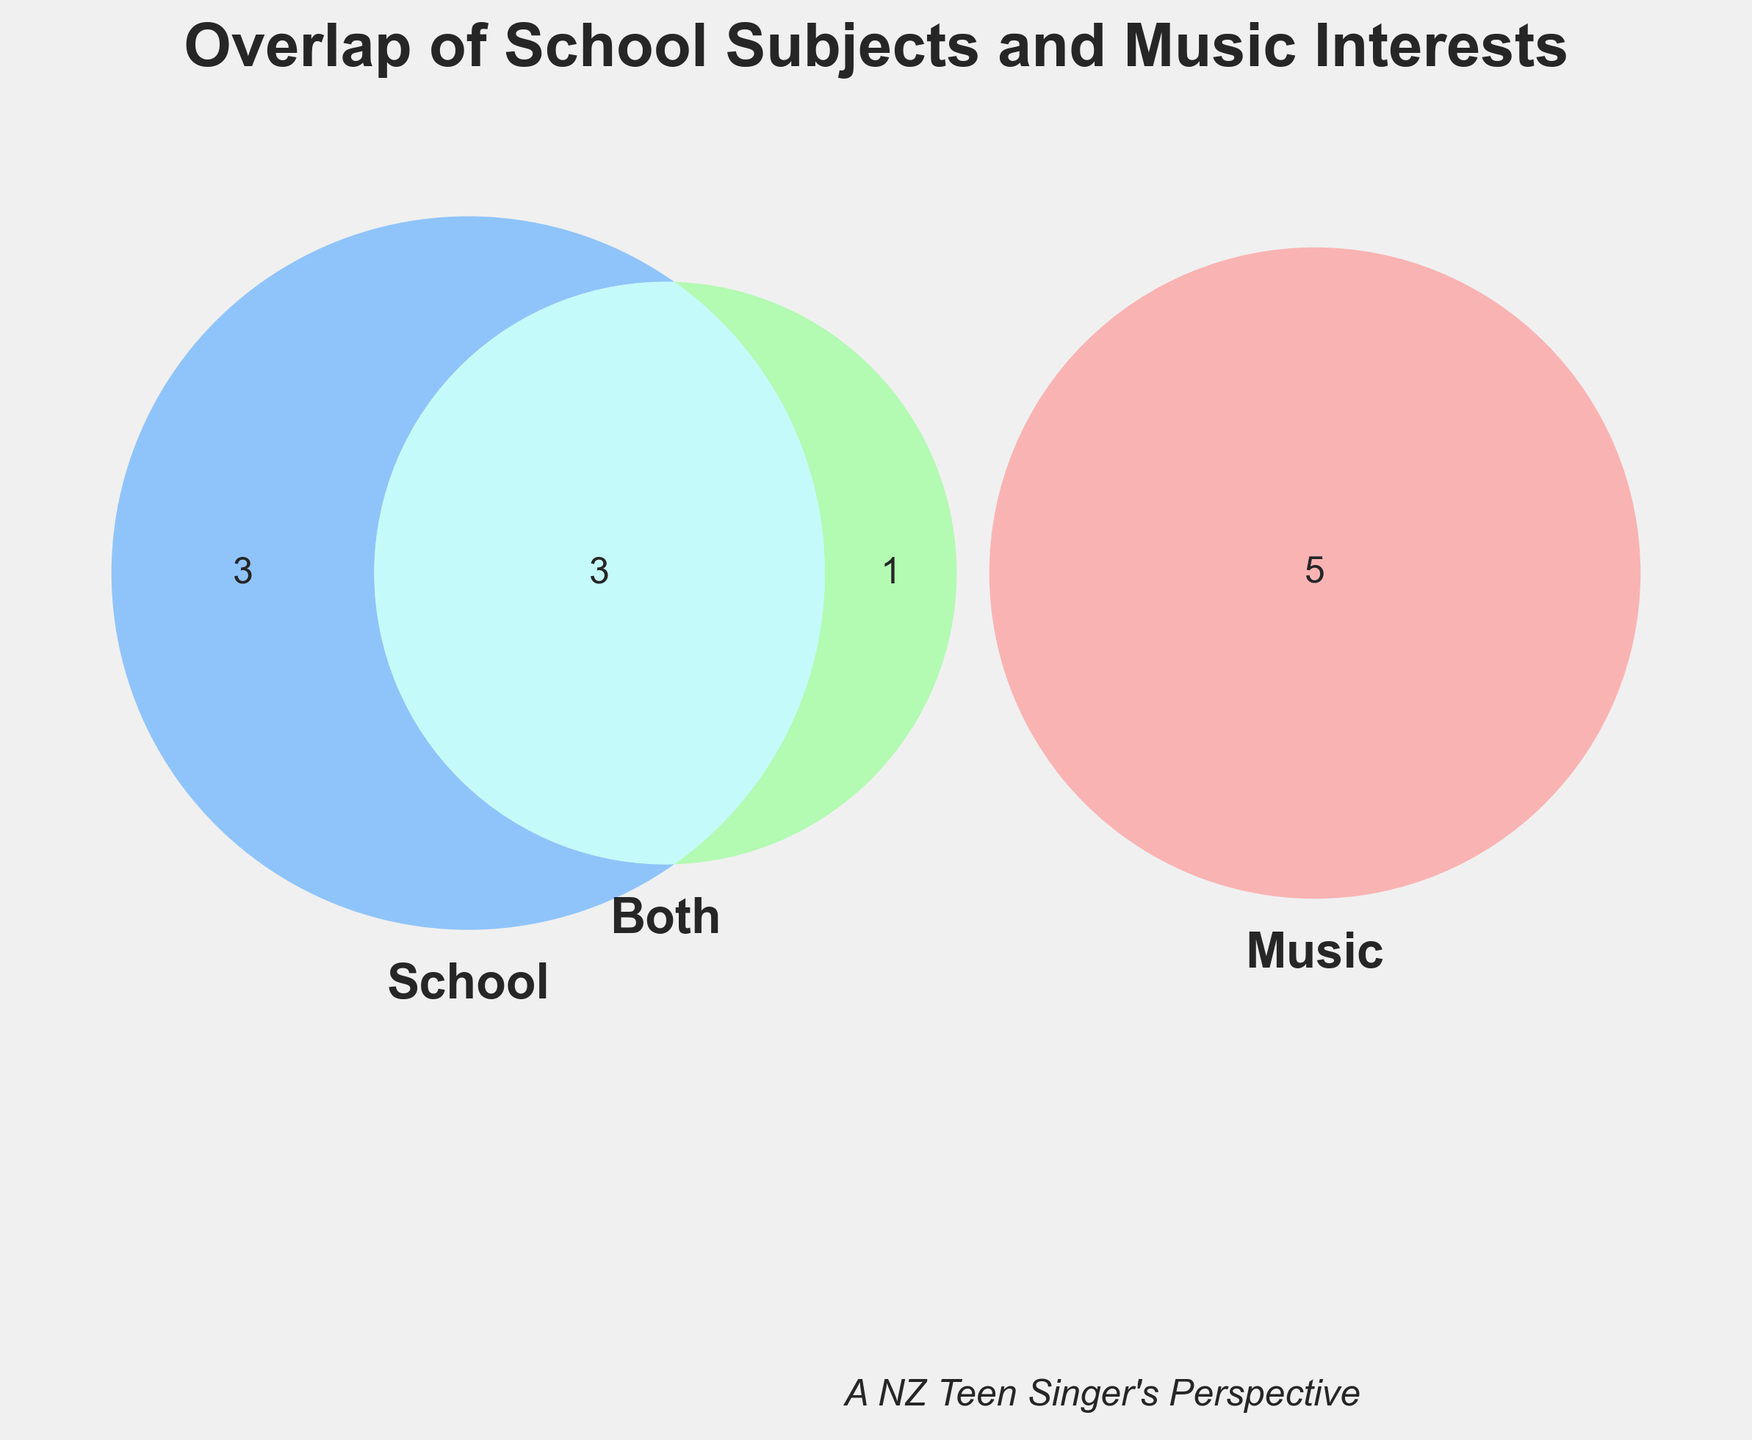What's the title of the Venn Diagram? The title is usually prominently placed at the top of the figure. Here, the title is "Overlap of School Subjects and Music Interests".
Answer: Overlap of School Subjects and Music Interests How many subjects are related to music but not school? This can be identified by looking at the section of the Venn Diagram that only intersects with "Music" and not "School". There are 6 subjects in this set: "Lyrics writing", "Music theory", "Voice training", "Music history", "Songwriting", and "Vocal health".
Answer: 6 Which subjects overlap between music and school? Overlap means the subjects appear in both "Music" and "School". These are: "Mathematics", "Literature", and "Public speaking".
Answer: Mathematics, Literature, Public speaking How many school subjects do not have any overlap with music interests? These are the subjects that only fall under the "School" category and do not intersect with "Music". They are "Physics", "Chemistry", and "Biology".
Answer: 3 Which category contains 'Voice training'? By inspecting the Venn Diagram, 'Voice training' is located in the section that only represents "Music".
Answer: Music only Are there subjects that overlap between all three categories? The Venn Diagram shows no intersection among "Music", "School", and a separate "Both" category altogether. Thus, no subjects fit into all three categories.
Answer: No Which category has the highest number of subjects? By counting the number of entries in each category: Music (6), School (6), Both (3), we see that both "Music" and "School" have the highest number of subjects.
Answer: Music and School Is 'Public speaking' a subject in music interests? 'Public speaking' can be found where "Both" overlaps, indicating it is related to both "Music" and "School".
Answer: Yes What is the unique color of the 'Music' set? The specific color used to represent "Music" is often identified in the Venn Diagram legend. In this diagram, 'Music' is represented in pink.
Answer: Pink 